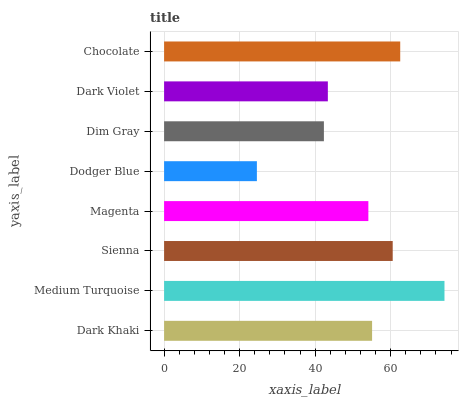Is Dodger Blue the minimum?
Answer yes or no. Yes. Is Medium Turquoise the maximum?
Answer yes or no. Yes. Is Sienna the minimum?
Answer yes or no. No. Is Sienna the maximum?
Answer yes or no. No. Is Medium Turquoise greater than Sienna?
Answer yes or no. Yes. Is Sienna less than Medium Turquoise?
Answer yes or no. Yes. Is Sienna greater than Medium Turquoise?
Answer yes or no. No. Is Medium Turquoise less than Sienna?
Answer yes or no. No. Is Dark Khaki the high median?
Answer yes or no. Yes. Is Magenta the low median?
Answer yes or no. Yes. Is Sienna the high median?
Answer yes or no. No. Is Chocolate the low median?
Answer yes or no. No. 